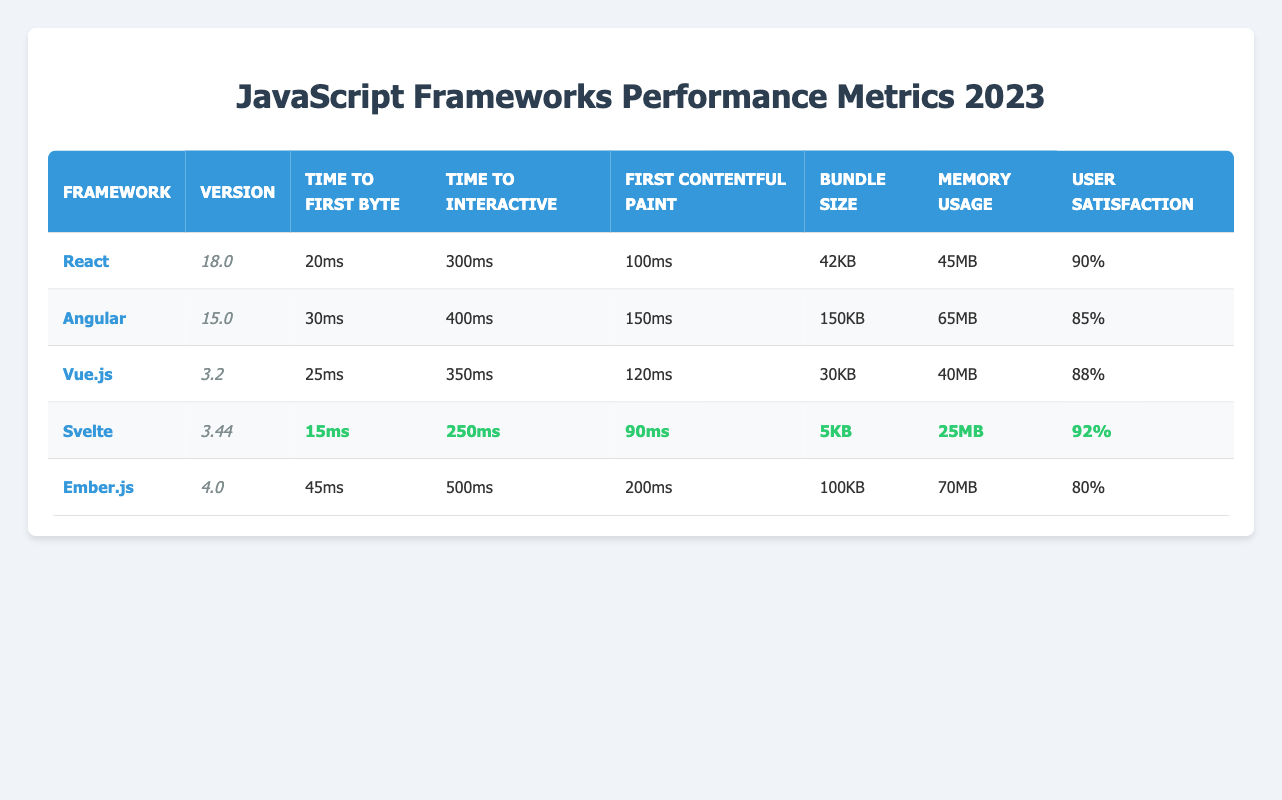What is the bundle size of Svelte? In the table, the bundle size for Svelte is listed under the "Bundle Size" column, and it shows "5KB."
Answer: 5KB Which framework has the highest user satisfaction? By comparing the "User Satisfaction" values, Svelte has 92%, which is the highest value in the table compared to others.
Answer: Svelte What is the time to first byte for Angular? The table specifies that Angular's time to first byte is "30ms," which can be found in the respective row for Angular.
Answer: 30ms Calculate the average memory usage of the frameworks listed. The memory usage values are: 45MB (React), 65MB (Angular), 40MB (Vue.js), 25MB (Svelte), and 70MB (Ember.js). Summing these gives 45 + 65 + 40 + 25 + 70 = 245MB. Dividing by the total number of frameworks (5) results in an average of 245MB / 5 = 49MB.
Answer: 49MB Does Vue.js have a lower bundle size than Angular? Comparing the bundle sizes, Vue.js has 30KB, while Angular has 150KB. Since 30KB is less than 150KB, the statement is true.
Answer: Yes Which framework has the longest time to interactive? In the table, the times to interactive are listed as: 300ms (React), 400ms (Angular), 350ms (Vue.js), 250ms (Svelte), and 500ms (Ember.js). The longest duration is 500ms for Ember.js.
Answer: Ember.js Is the first contentful paint for Svelte better than that of React? Examining the values, Svelte's first contentful paint is "90ms," while React's is "100ms." Since "90ms" is better (lower) than "100ms," Svelte performs better in this metric.
Answer: Yes What is the difference in user satisfaction between React and Ember.js? The user satisfaction for React is 90%, and for Ember.js, it is 80%. The difference is calculated as 90% - 80% = 10%.
Answer: 10% Which framework has the fastest time to first byte and how much is it? Looking at the time to first byte across frameworks, Svelte has the fastest at "15ms," which is the lowest value in that column.
Answer: 15ms Are the rendering performance metrics for Angular all better than those of Vue.js? The rendering metrics for Angular are: 30ms (TTFB), 400ms (TTI), and 150ms (FCP). For Vue.js, the metrics are 25ms (TTFB), 350ms (TTI), and 120ms (FCP). Since Vue.js has lower (better) values for all these metrics, the statement is false.
Answer: No What is the total bundle size of all the frameworks combined? The bundle sizes are: 42KB (React), 150KB (Angular), 30KB (Vue.js), 5KB (Svelte), and 100KB (Ember.js). Adding these together gives 42 + 150 + 30 + 5 + 100 = 327KB.
Answer: 327KB 